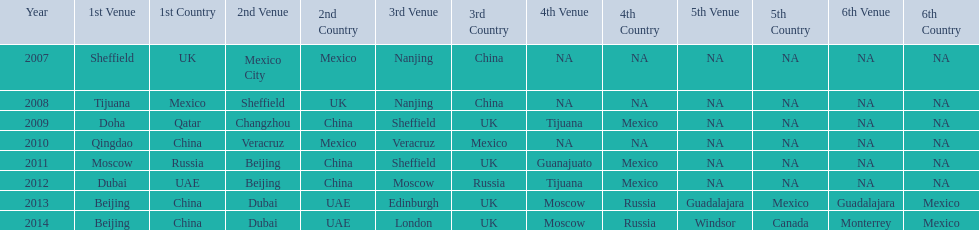Between 2007 and 2012, which two locations had no countries represented? 5th Venue, 6th Venue. 